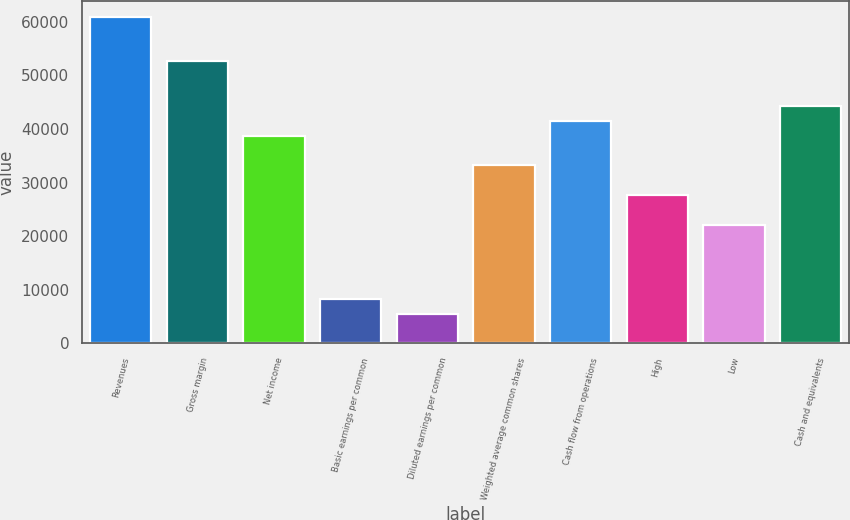Convert chart. <chart><loc_0><loc_0><loc_500><loc_500><bar_chart><fcel>Revenues<fcel>Gross margin<fcel>Net income<fcel>Basic earnings per common<fcel>Diluted earnings per common<fcel>Weighted average common shares<fcel>Cash flow from operations<fcel>High<fcel>Low<fcel>Cash and equivalents<nl><fcel>60934.8<fcel>52625.6<fcel>38776.8<fcel>8309.55<fcel>5539.8<fcel>33237.3<fcel>41546.6<fcel>27697.8<fcel>22158.3<fcel>44316.3<nl></chart> 